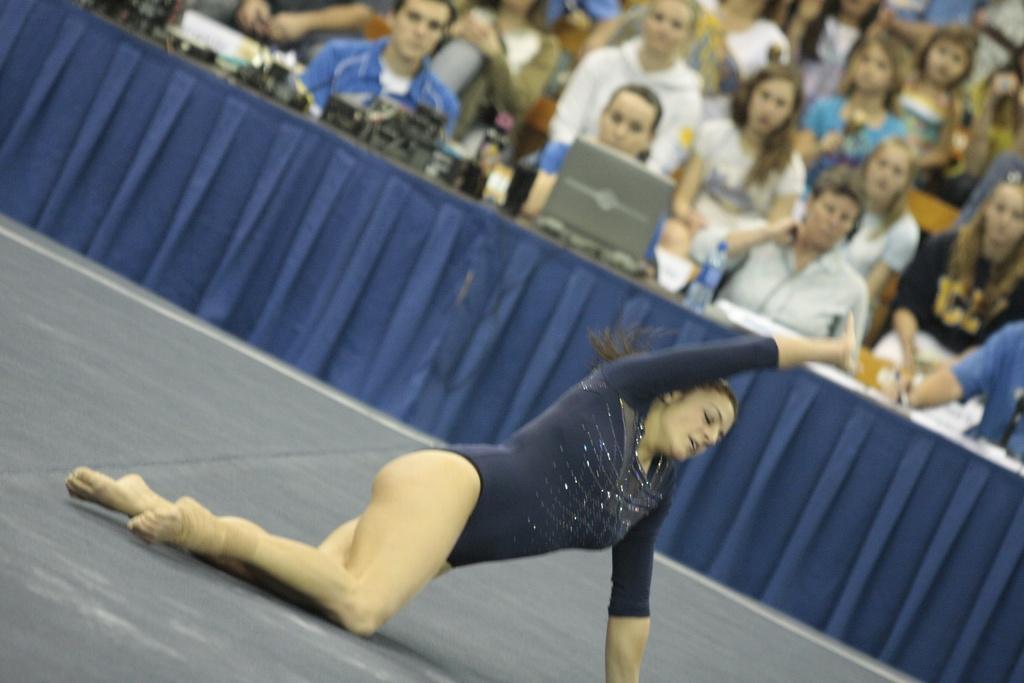Please provide a concise description of this image. In this image we can see a woman on the floor. In the background, we can see the spectators sitting on the chairs and they are on the right side. Here we can see the table. Here we can see a laptop and water bottles are kept on it. 